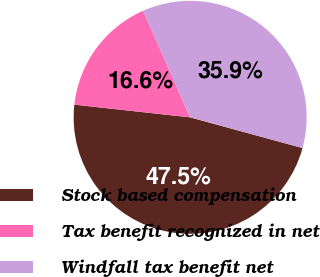<chart> <loc_0><loc_0><loc_500><loc_500><pie_chart><fcel>Stock based compensation<fcel>Tax benefit recognized in net<fcel>Windfall tax benefit net<nl><fcel>47.5%<fcel>16.65%<fcel>35.86%<nl></chart> 